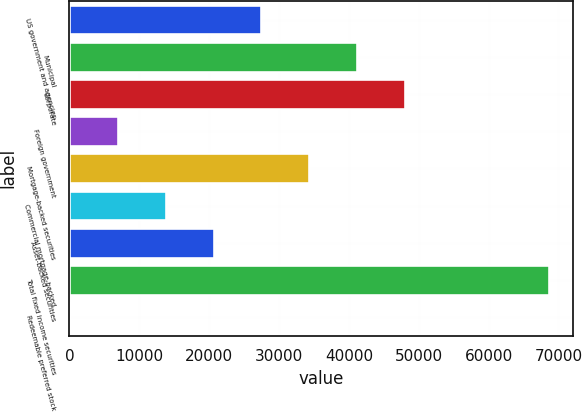Convert chart to OTSL. <chart><loc_0><loc_0><loc_500><loc_500><bar_chart><fcel>US government and agencies<fcel>Municipal<fcel>Corporate<fcel>Foreign government<fcel>Mortgage-backed securities<fcel>Commercial mortgage-backed<fcel>Asset-backed securities<fcel>Total fixed income securities<fcel>Redeemable preferred stock<nl><fcel>27482.2<fcel>41190.8<fcel>48045.1<fcel>6919.3<fcel>34336.5<fcel>13773.6<fcel>20627.9<fcel>68608<fcel>65<nl></chart> 